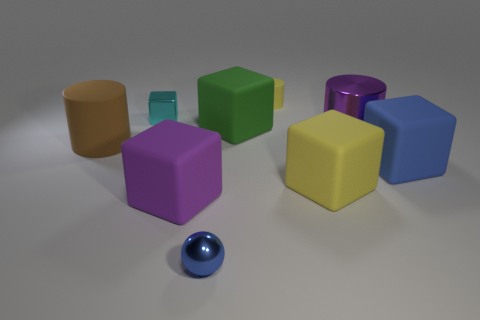Are there any large green rubber objects right of the blue sphere?
Your answer should be very brief. Yes. What is the large purple cube made of?
Provide a succinct answer. Rubber. What shape is the blue object to the right of the large green block?
Your response must be concise. Cube. The block that is the same color as the shiny cylinder is what size?
Provide a succinct answer. Large. Is there a yellow rubber cylinder of the same size as the purple metallic cylinder?
Provide a short and direct response. No. Do the big purple object that is to the left of the big green rubber thing and the big green block have the same material?
Offer a very short reply. Yes. Are there the same number of blue rubber things left of the small rubber cylinder and cyan things in front of the green rubber cube?
Provide a short and direct response. Yes. What is the shape of the object that is both behind the purple cylinder and to the left of the tiny blue ball?
Provide a short and direct response. Cube. How many shiny things are on the left side of the small rubber cylinder?
Offer a terse response. 2. What number of other things are there of the same shape as the green object?
Provide a short and direct response. 4. 